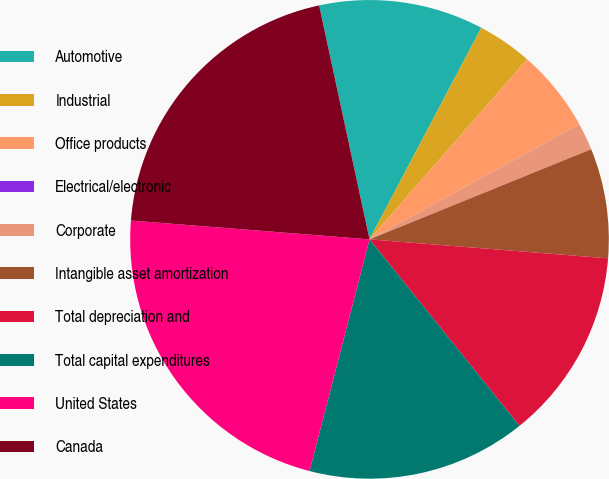Convert chart to OTSL. <chart><loc_0><loc_0><loc_500><loc_500><pie_chart><fcel>Automotive<fcel>Industrial<fcel>Office products<fcel>Electrical/electronic<fcel>Corporate<fcel>Intangible asset amortization<fcel>Total depreciation and<fcel>Total capital expenditures<fcel>United States<fcel>Canada<nl><fcel>11.11%<fcel>3.71%<fcel>5.56%<fcel>0.0%<fcel>1.85%<fcel>7.41%<fcel>12.96%<fcel>14.81%<fcel>22.22%<fcel>20.37%<nl></chart> 